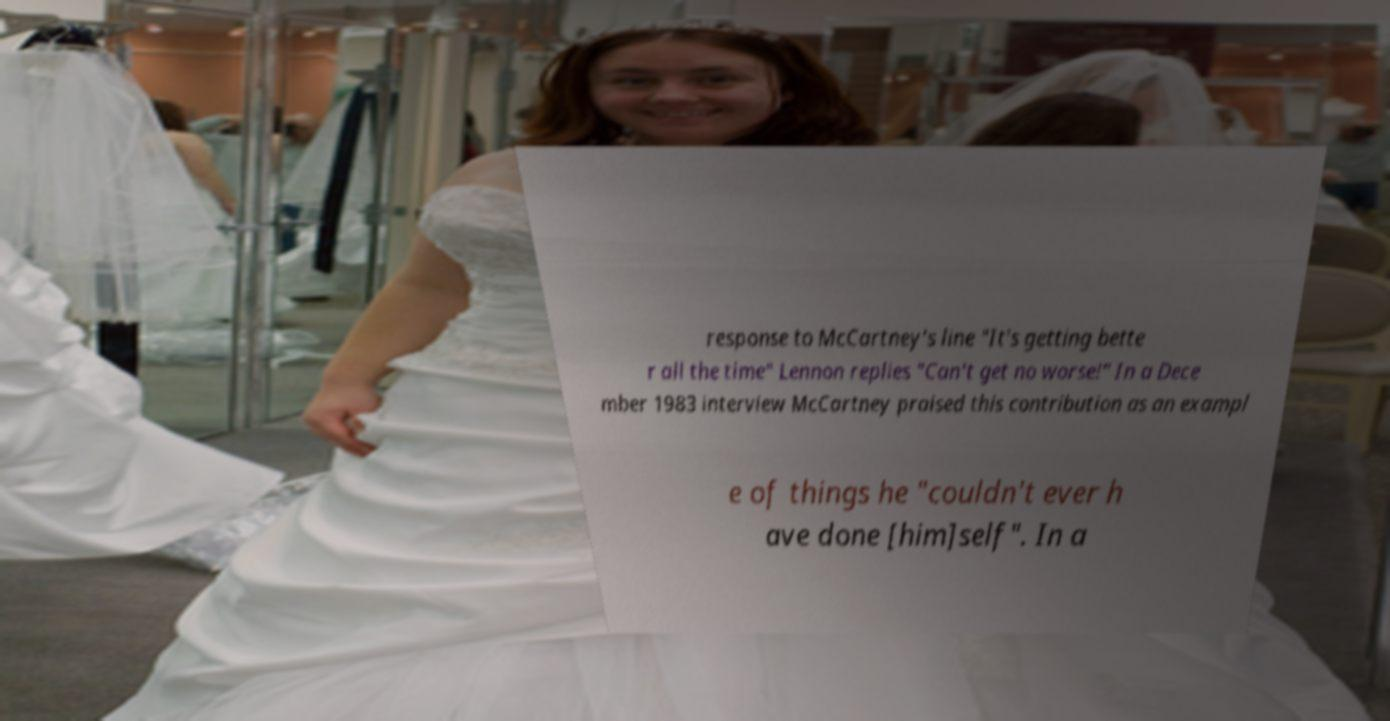Can you accurately transcribe the text from the provided image for me? response to McCartney's line "It's getting bette r all the time" Lennon replies "Can't get no worse!" In a Dece mber 1983 interview McCartney praised this contribution as an exampl e of things he "couldn't ever h ave done [him]self". In a 